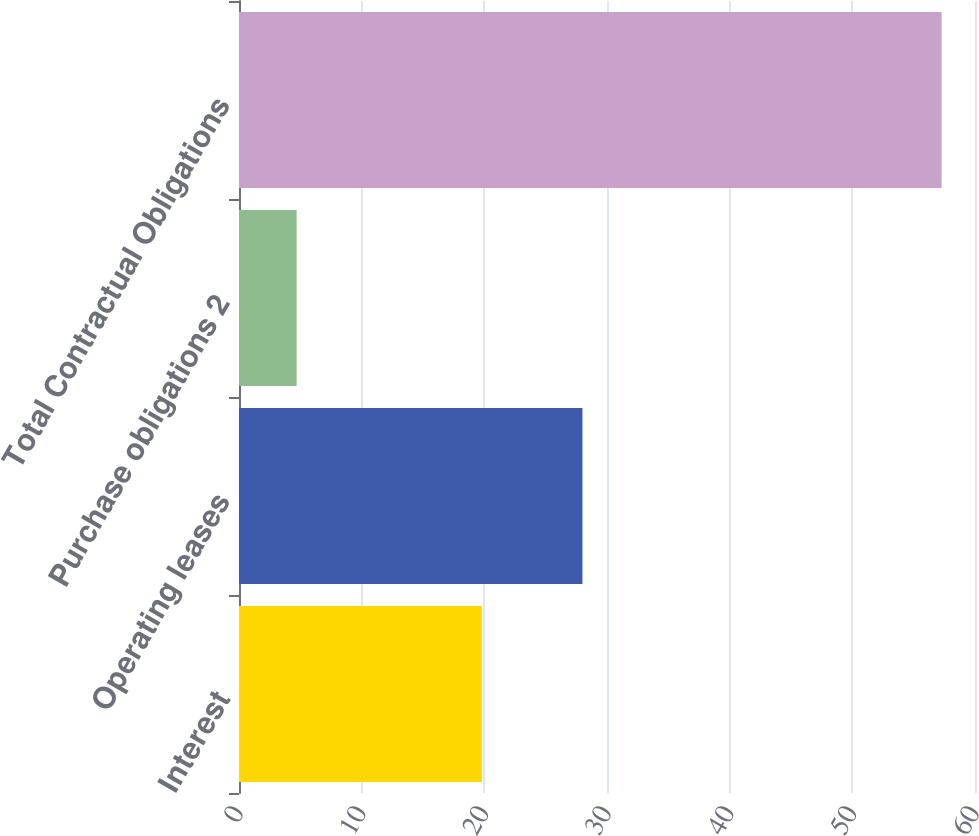Convert chart. <chart><loc_0><loc_0><loc_500><loc_500><bar_chart><fcel>Interest<fcel>Operating leases<fcel>Purchase obligations 2<fcel>Total Contractual Obligations<nl><fcel>19.8<fcel>28<fcel>4.7<fcel>57.28<nl></chart> 